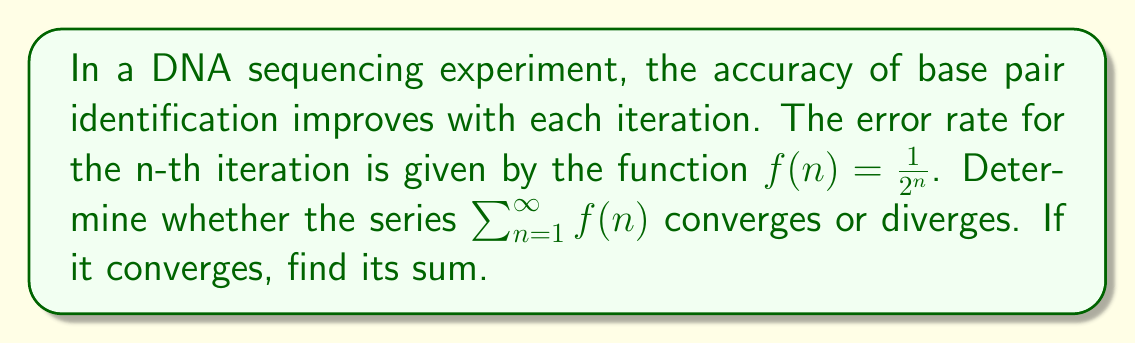Solve this math problem. To evaluate the convergence of this series, we can use the concept of geometric series from real analysis.

1) First, let's identify the general term of the series:
   $a_n = f(n) = \frac{1}{2^n}$

2) This is a geometric series with first term $a = \frac{1}{2}$ and common ratio $r = \frac{1}{2}$.

3) For a geometric series $\sum_{n=1}^{\infty} ar^{n-1}$, we know that it converges if and only if $|r| < 1$.

4) In this case, $r = \frac{1}{2}$, so $|r| = \frac{1}{2} < 1$. Therefore, the series converges.

5) For a convergent geometric series, the sum is given by the formula:
   $S_{\infty} = \frac{a}{1-r}$, where $a$ is the first term and $r$ is the common ratio.

6) Substituting our values:
   $S_{\infty} = \frac{\frac{1}{2}}{1-\frac{1}{2}} = \frac{\frac{1}{2}}{\frac{1}{2}} = 1$

Therefore, the series converges and its sum is 1.

In the context of DNA sequencing, this means that the cumulative error rate across all iterations is finite and equal to 1, suggesting that the sequencing process becomes increasingly accurate with each iteration, with the total error never exceeding 100%.
Answer: The series $\sum_{n=1}^{\infty} \frac{1}{2^n}$ converges, and its sum is 1. 